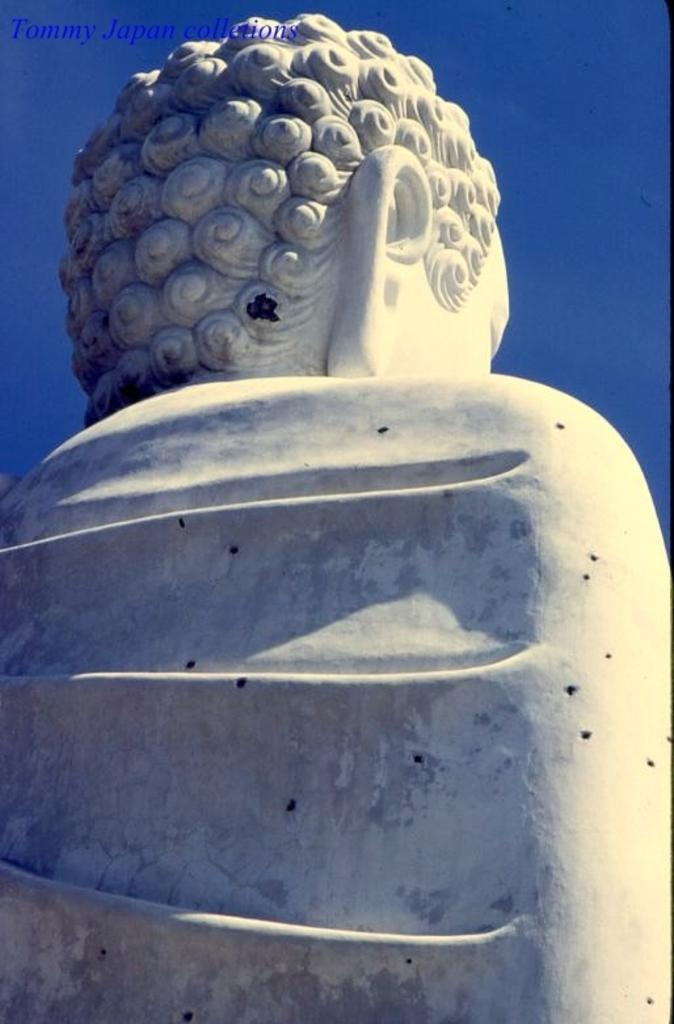What is the main subject of the picture? There is a statue of Buddha in the picture. What color is the background of the image? The background of the image is blue. Is there any additional information or marking on the image? Yes, there is a watermark on the image. What type of tools does the doctor use in the image? There is no doctor present in the image; it features a statue of Buddha with a blue background and a watermark. What kind of flowers can be seen in the image? There are no flowers present in the image; it features a statue of Buddha with a blue background and a watermark. 